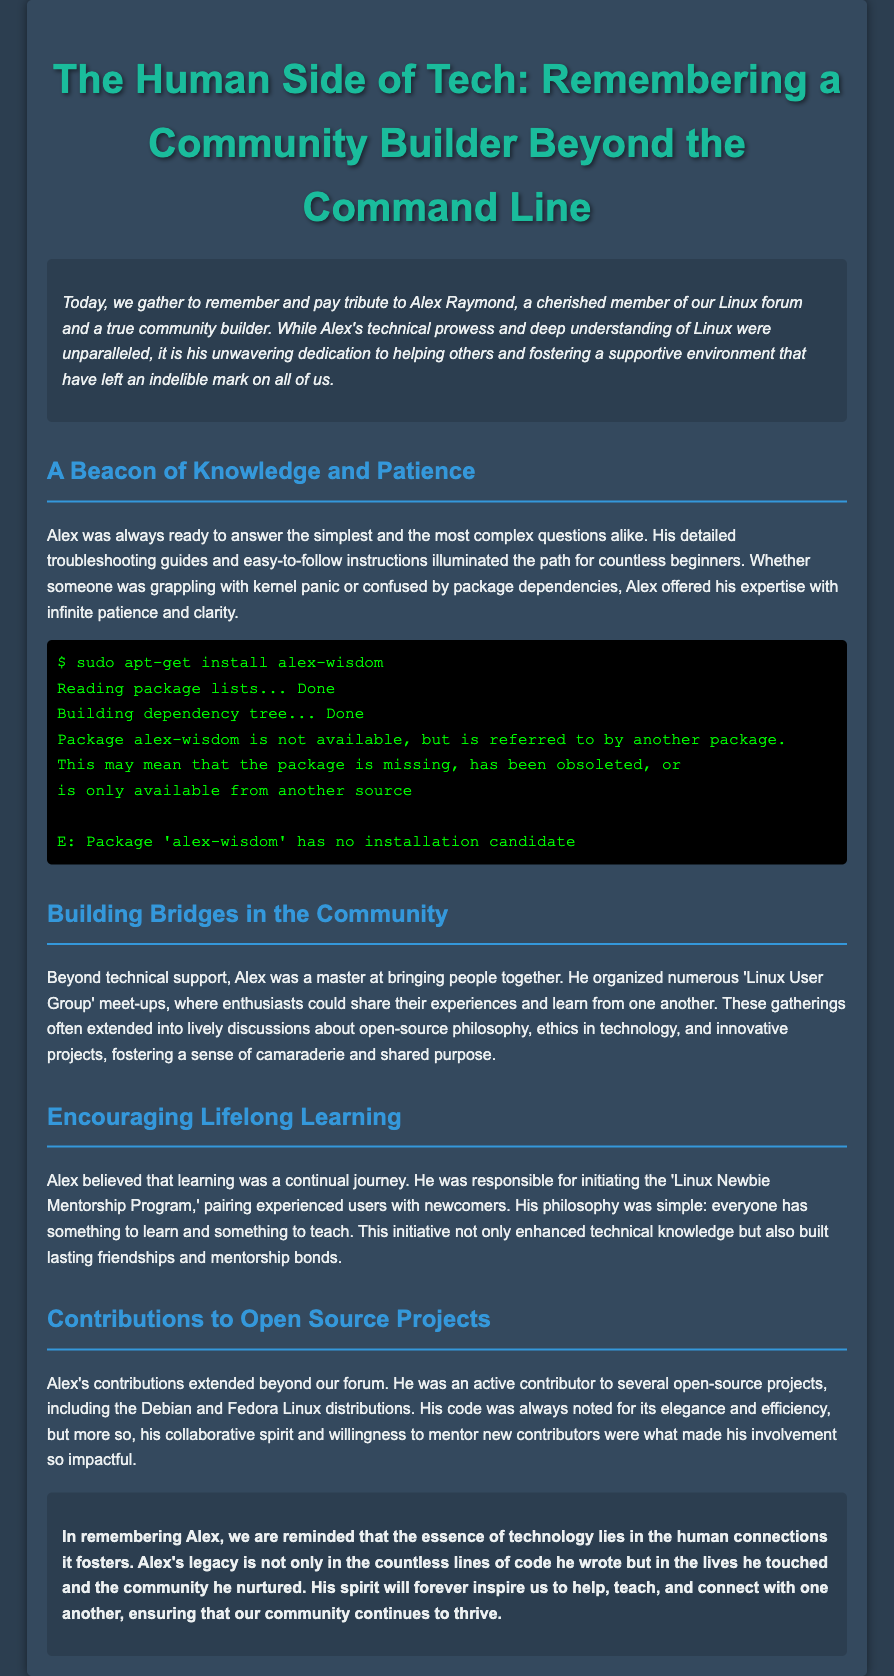What was Alex Raymond known for? Alex Raymond was known for being a cherished member of the Linux forum and a true community builder.
Answer: Community builder What initiated the 'Linux Newbie Mentorship Program'? The program was initiated by Alex to pair experienced users with newcomers.
Answer: Alex What key qualities did Alex demonstrate in helping others? Alex demonstrated detailed troubleshooting guides and infinite patience while helping others.
Answer: Patience How did Alex contribute to open-source projects? Alex was an active contributor to several open-source projects, including Debian and Fedora.
Answer: Debian and Fedora What philosophy did Alex hold about learning? Alex believed that everyone has something to learn and something to teach.
Answer: Lifelong learning What role did Alex play in community gatherings? Alex organized numerous 'Linux User Group' meet-ups for enthusiasts to share experiences.
Answer: Organizer What does Alex's legacy in the community signify? Alex's legacy signifies the importance of human connections in technology.
Answer: Human connections What color is used for the main title in the document? The color used for the main title is a shade of green.
Answer: Green 